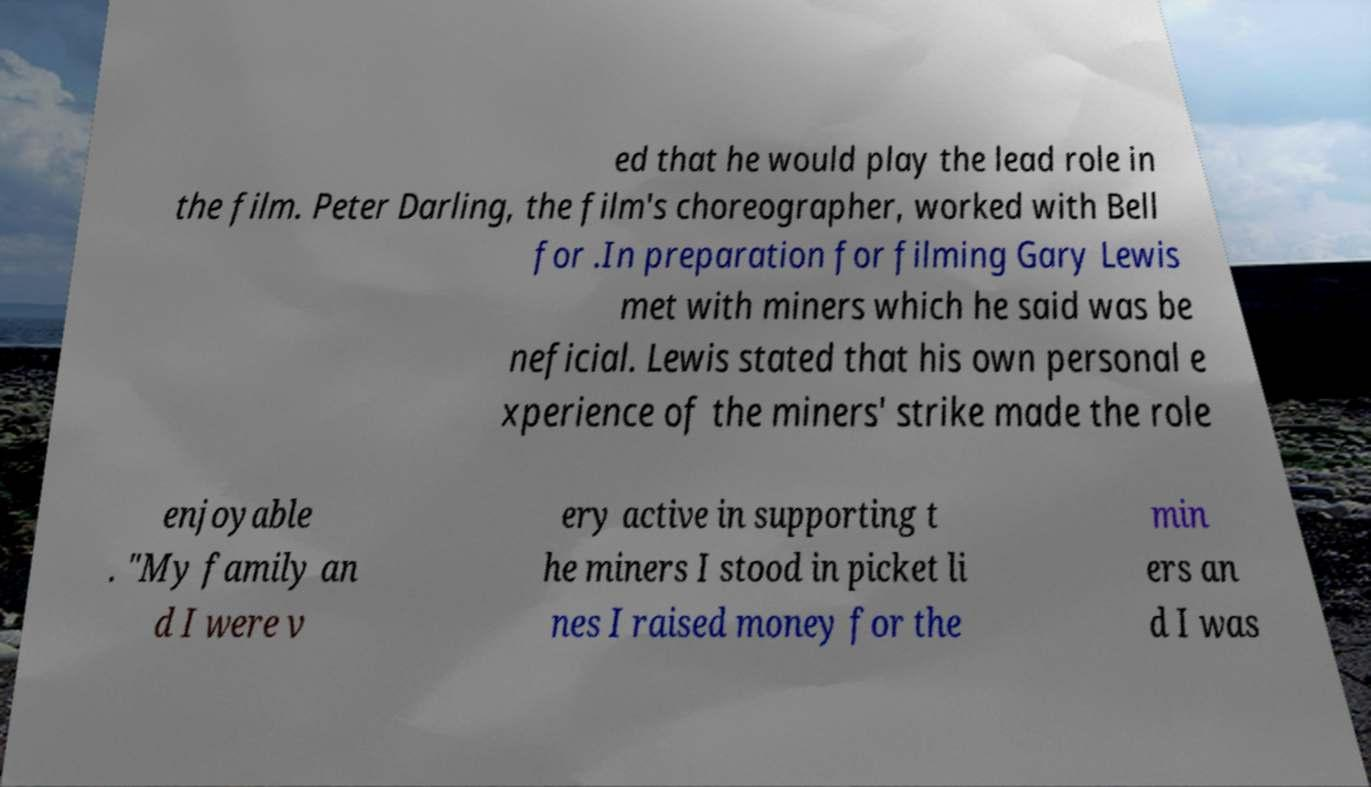There's text embedded in this image that I need extracted. Can you transcribe it verbatim? ed that he would play the lead role in the film. Peter Darling, the film's choreographer, worked with Bell for .In preparation for filming Gary Lewis met with miners which he said was be neficial. Lewis stated that his own personal e xperience of the miners' strike made the role enjoyable . "My family an d I were v ery active in supporting t he miners I stood in picket li nes I raised money for the min ers an d I was 